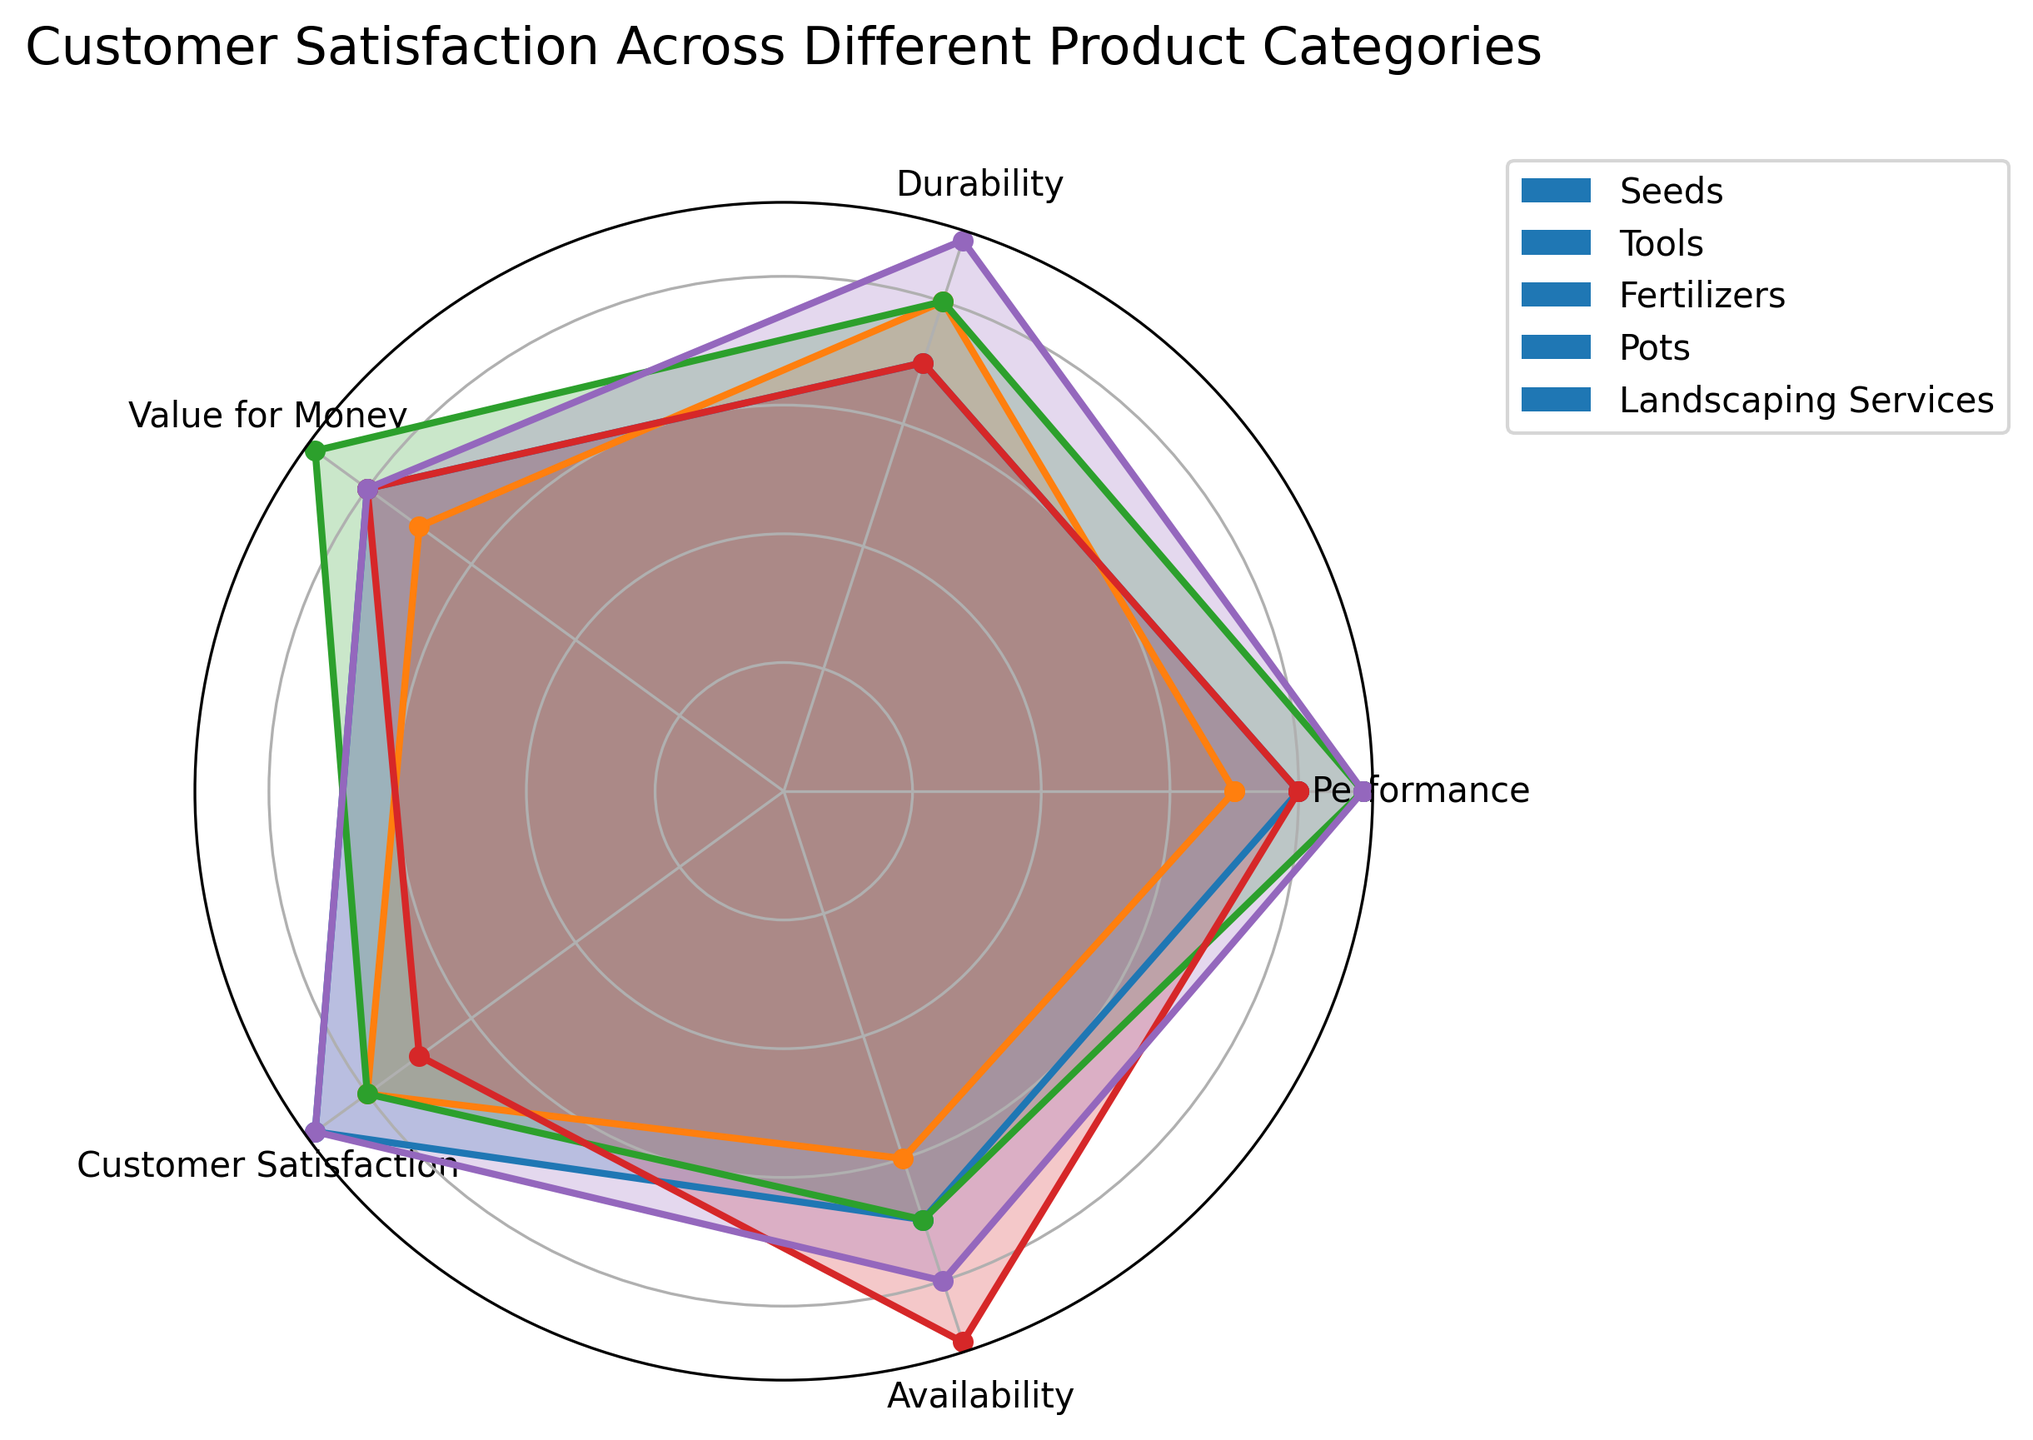What's the best category for Customer Satisfaction? Looking at the chart, the highest Customer Satisfaction score is associated with Seeds and Landscaping Services, each scoring a 9.
Answer: Seeds, Landscaping Services Which category has the lowest Availability? The lowest Availability score in the chart is for Tools, which has a score of 6.
Answer: Tools Which two categories have the same Performance score? Both Seeds and Pots have a Performance score of 8, as shown in the chart.
Answer: Seeds, Pots What's the average Value for Money score across all categories? Summing the Value for Money scores for all categories (8, 7, 9, 8, 8) gives 40. Divided by the 5 categories, the average score is 40/5 = 8.
Answer: 8 How does the Durability score of Landscaping Services compare with Seeds? The Durability score for Landscaping Services is 9, while for Seeds it is 7, indicating Landscaping Services have higher Durability.
Answer: Landscaping Services > Seeds Which categories have an equal Customer Satisfaction score of 8? According to the chart, both Tools and Fertilizers have a Customer Satisfaction score of 8.
Answer: Tools, Fertilizers What's the sum of the Availability scores for Seeds and Fertilizers? The Availability score for Seeds is 7 and for Fertilizers is 7. Summing them gives 7 + 7 = 14.
Answer: 14 Which category scores highest in both Performance and Durability? Landscaping Services score the highest in Performance (9) and has the highest score in Durability (9).
Answer: Landscaping Services 